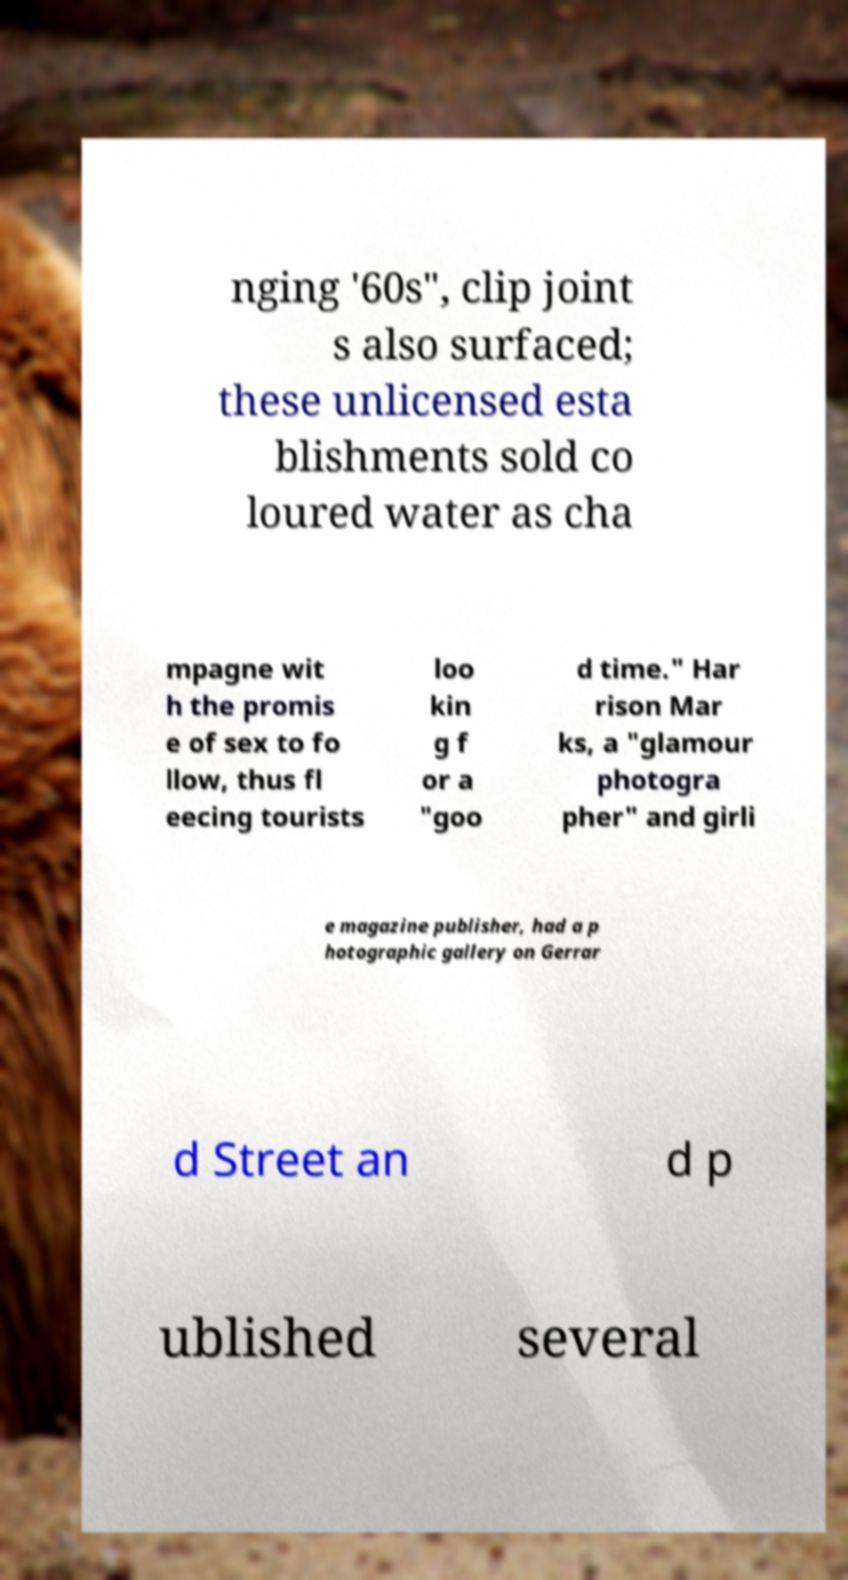What messages or text are displayed in this image? I need them in a readable, typed format. nging '60s", clip joint s also surfaced; these unlicensed esta blishments sold co loured water as cha mpagne wit h the promis e of sex to fo llow, thus fl eecing tourists loo kin g f or a "goo d time." Har rison Mar ks, a "glamour photogra pher" and girli e magazine publisher, had a p hotographic gallery on Gerrar d Street an d p ublished several 